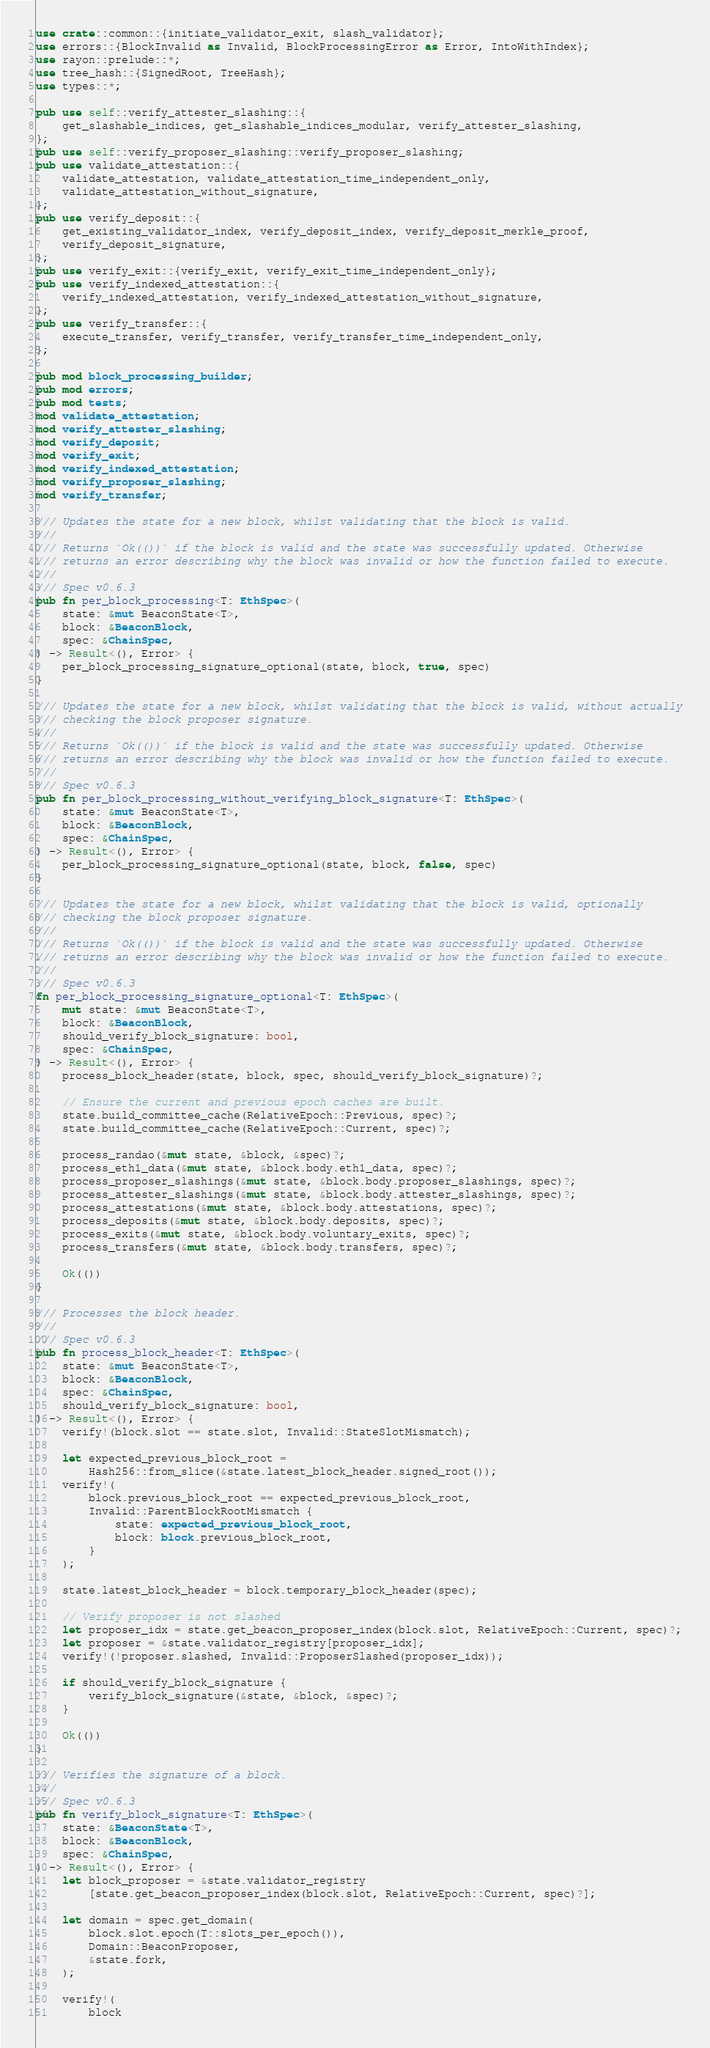<code> <loc_0><loc_0><loc_500><loc_500><_Rust_>use crate::common::{initiate_validator_exit, slash_validator};
use errors::{BlockInvalid as Invalid, BlockProcessingError as Error, IntoWithIndex};
use rayon::prelude::*;
use tree_hash::{SignedRoot, TreeHash};
use types::*;

pub use self::verify_attester_slashing::{
    get_slashable_indices, get_slashable_indices_modular, verify_attester_slashing,
};
pub use self::verify_proposer_slashing::verify_proposer_slashing;
pub use validate_attestation::{
    validate_attestation, validate_attestation_time_independent_only,
    validate_attestation_without_signature,
};
pub use verify_deposit::{
    get_existing_validator_index, verify_deposit_index, verify_deposit_merkle_proof,
    verify_deposit_signature,
};
pub use verify_exit::{verify_exit, verify_exit_time_independent_only};
pub use verify_indexed_attestation::{
    verify_indexed_attestation, verify_indexed_attestation_without_signature,
};
pub use verify_transfer::{
    execute_transfer, verify_transfer, verify_transfer_time_independent_only,
};

pub mod block_processing_builder;
pub mod errors;
pub mod tests;
mod validate_attestation;
mod verify_attester_slashing;
mod verify_deposit;
mod verify_exit;
mod verify_indexed_attestation;
mod verify_proposer_slashing;
mod verify_transfer;

/// Updates the state for a new block, whilst validating that the block is valid.
///
/// Returns `Ok(())` if the block is valid and the state was successfully updated. Otherwise
/// returns an error describing why the block was invalid or how the function failed to execute.
///
/// Spec v0.6.3
pub fn per_block_processing<T: EthSpec>(
    state: &mut BeaconState<T>,
    block: &BeaconBlock,
    spec: &ChainSpec,
) -> Result<(), Error> {
    per_block_processing_signature_optional(state, block, true, spec)
}

/// Updates the state for a new block, whilst validating that the block is valid, without actually
/// checking the block proposer signature.
///
/// Returns `Ok(())` if the block is valid and the state was successfully updated. Otherwise
/// returns an error describing why the block was invalid or how the function failed to execute.
///
/// Spec v0.6.3
pub fn per_block_processing_without_verifying_block_signature<T: EthSpec>(
    state: &mut BeaconState<T>,
    block: &BeaconBlock,
    spec: &ChainSpec,
) -> Result<(), Error> {
    per_block_processing_signature_optional(state, block, false, spec)
}

/// Updates the state for a new block, whilst validating that the block is valid, optionally
/// checking the block proposer signature.
///
/// Returns `Ok(())` if the block is valid and the state was successfully updated. Otherwise
/// returns an error describing why the block was invalid or how the function failed to execute.
///
/// Spec v0.6.3
fn per_block_processing_signature_optional<T: EthSpec>(
    mut state: &mut BeaconState<T>,
    block: &BeaconBlock,
    should_verify_block_signature: bool,
    spec: &ChainSpec,
) -> Result<(), Error> {
    process_block_header(state, block, spec, should_verify_block_signature)?;

    // Ensure the current and previous epoch caches are built.
    state.build_committee_cache(RelativeEpoch::Previous, spec)?;
    state.build_committee_cache(RelativeEpoch::Current, spec)?;

    process_randao(&mut state, &block, &spec)?;
    process_eth1_data(&mut state, &block.body.eth1_data, spec)?;
    process_proposer_slashings(&mut state, &block.body.proposer_slashings, spec)?;
    process_attester_slashings(&mut state, &block.body.attester_slashings, spec)?;
    process_attestations(&mut state, &block.body.attestations, spec)?;
    process_deposits(&mut state, &block.body.deposits, spec)?;
    process_exits(&mut state, &block.body.voluntary_exits, spec)?;
    process_transfers(&mut state, &block.body.transfers, spec)?;

    Ok(())
}

/// Processes the block header.
///
/// Spec v0.6.3
pub fn process_block_header<T: EthSpec>(
    state: &mut BeaconState<T>,
    block: &BeaconBlock,
    spec: &ChainSpec,
    should_verify_block_signature: bool,
) -> Result<(), Error> {
    verify!(block.slot == state.slot, Invalid::StateSlotMismatch);

    let expected_previous_block_root =
        Hash256::from_slice(&state.latest_block_header.signed_root());
    verify!(
        block.previous_block_root == expected_previous_block_root,
        Invalid::ParentBlockRootMismatch {
            state: expected_previous_block_root,
            block: block.previous_block_root,
        }
    );

    state.latest_block_header = block.temporary_block_header(spec);

    // Verify proposer is not slashed
    let proposer_idx = state.get_beacon_proposer_index(block.slot, RelativeEpoch::Current, spec)?;
    let proposer = &state.validator_registry[proposer_idx];
    verify!(!proposer.slashed, Invalid::ProposerSlashed(proposer_idx));

    if should_verify_block_signature {
        verify_block_signature(&state, &block, &spec)?;
    }

    Ok(())
}

/// Verifies the signature of a block.
///
/// Spec v0.6.3
pub fn verify_block_signature<T: EthSpec>(
    state: &BeaconState<T>,
    block: &BeaconBlock,
    spec: &ChainSpec,
) -> Result<(), Error> {
    let block_proposer = &state.validator_registry
        [state.get_beacon_proposer_index(block.slot, RelativeEpoch::Current, spec)?];

    let domain = spec.get_domain(
        block.slot.epoch(T::slots_per_epoch()),
        Domain::BeaconProposer,
        &state.fork,
    );

    verify!(
        block</code> 